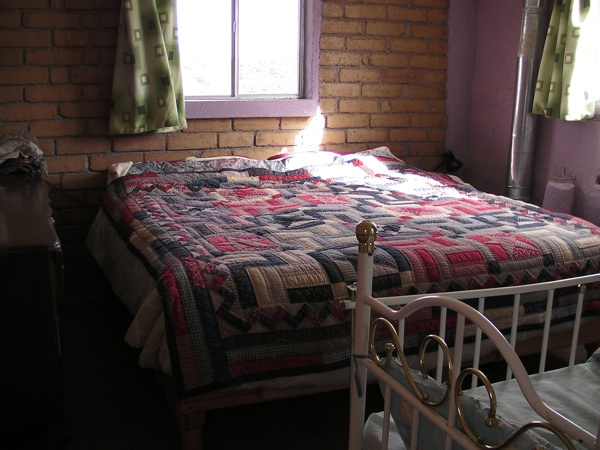Describe the objects in this image and their specific colors. I can see bed in black, gray, darkgray, and white tones and bed in black and gray tones in this image. 